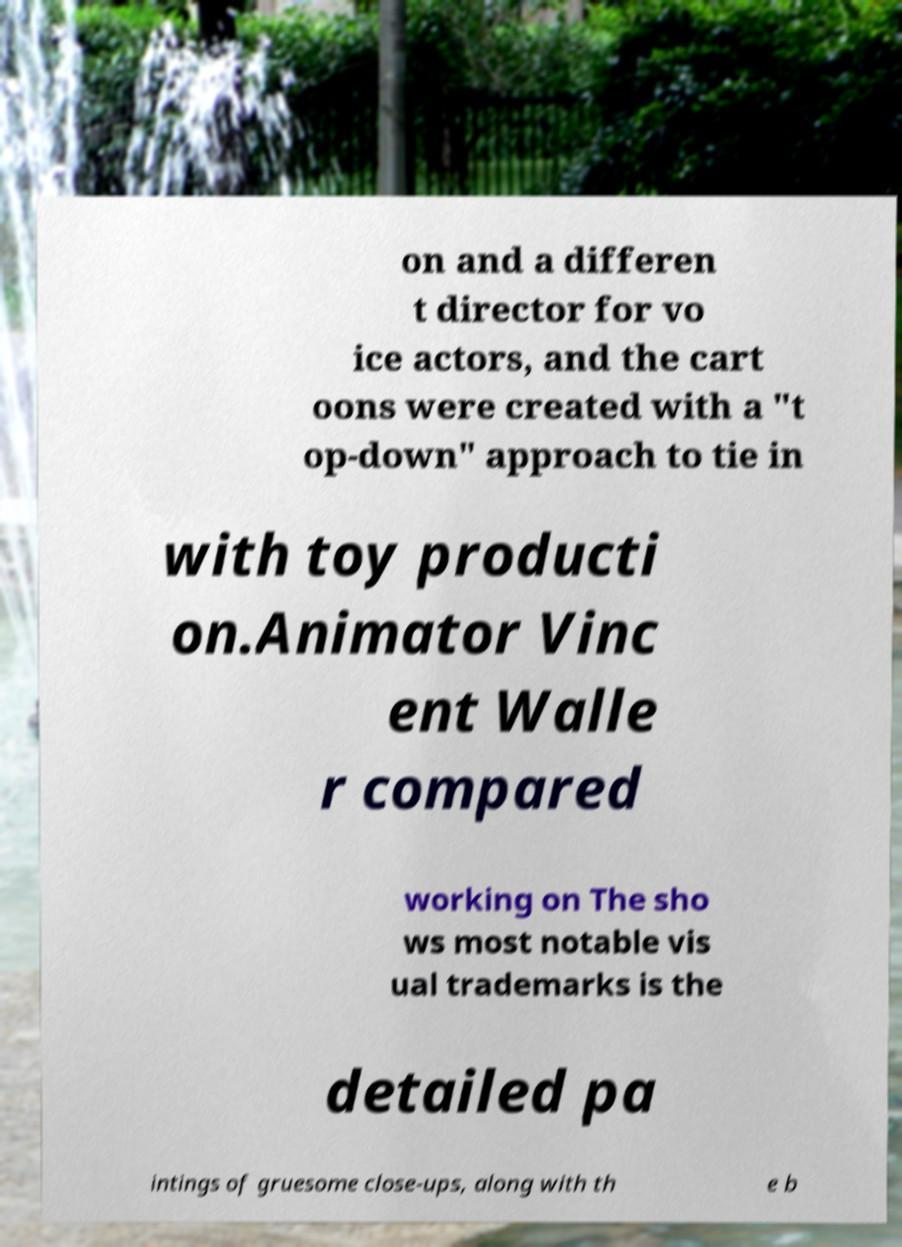Could you assist in decoding the text presented in this image and type it out clearly? on and a differen t director for vo ice actors, and the cart oons were created with a "t op-down" approach to tie in with toy producti on.Animator Vinc ent Walle r compared working on The sho ws most notable vis ual trademarks is the detailed pa intings of gruesome close-ups, along with th e b 